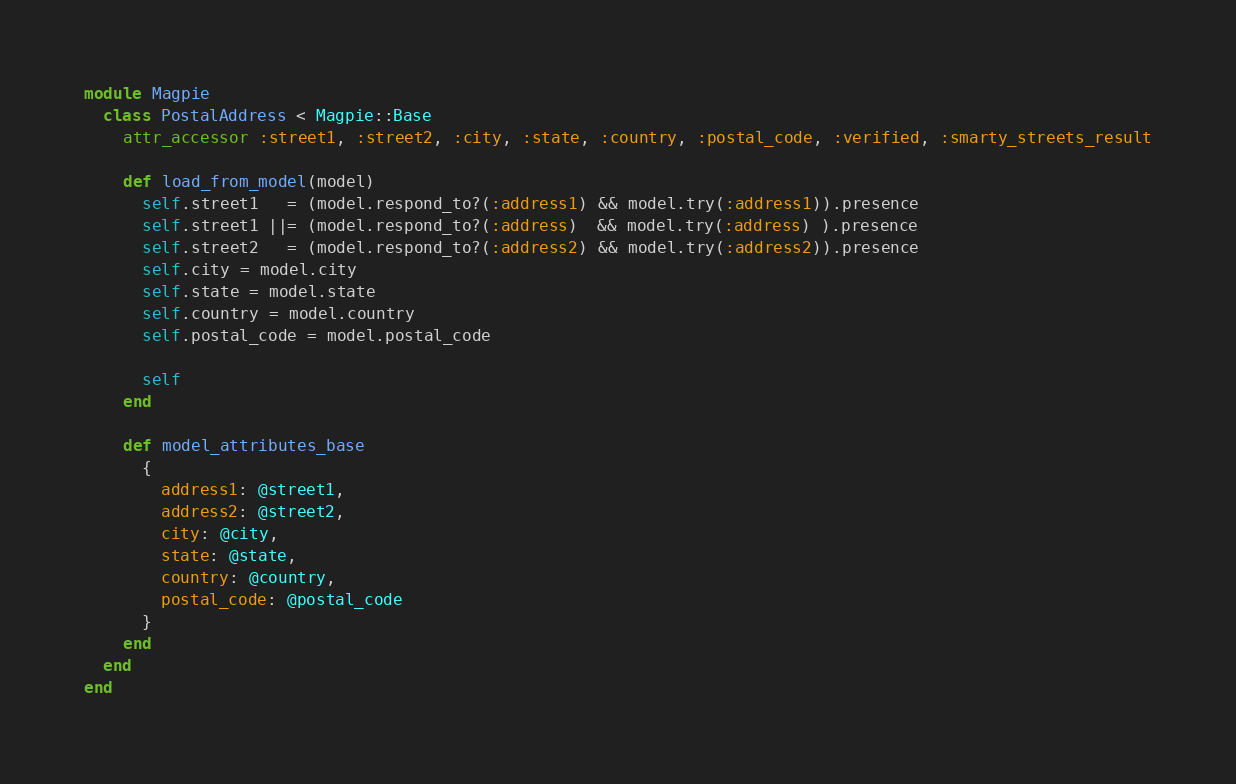<code> <loc_0><loc_0><loc_500><loc_500><_Ruby_>module Magpie
  class PostalAddress < Magpie::Base
    attr_accessor :street1, :street2, :city, :state, :country, :postal_code, :verified, :smarty_streets_result

    def load_from_model(model)
      self.street1   = (model.respond_to?(:address1) && model.try(:address1)).presence
      self.street1 ||= (model.respond_to?(:address)  && model.try(:address) ).presence
      self.street2   = (model.respond_to?(:address2) && model.try(:address2)).presence
      self.city = model.city
      self.state = model.state
      self.country = model.country
      self.postal_code = model.postal_code

      self
    end

    def model_attributes_base
      {
        address1: @street1,
        address2: @street2,
        city: @city,
        state: @state,
        country: @country,
        postal_code: @postal_code
      }
    end
  end
end
</code> 